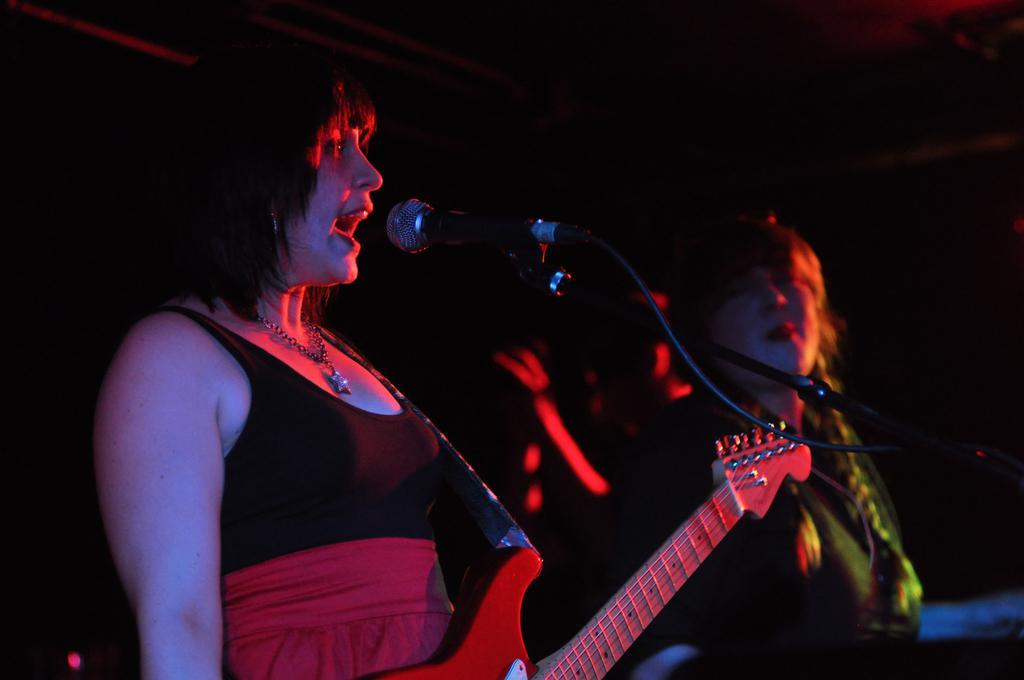Describe this image in one or two sentences. In this image there are group of musicians. Woman at the left side is standing and sitting in front of the mic holding a musical instrument along with her. At the right side the person is seen standing. 